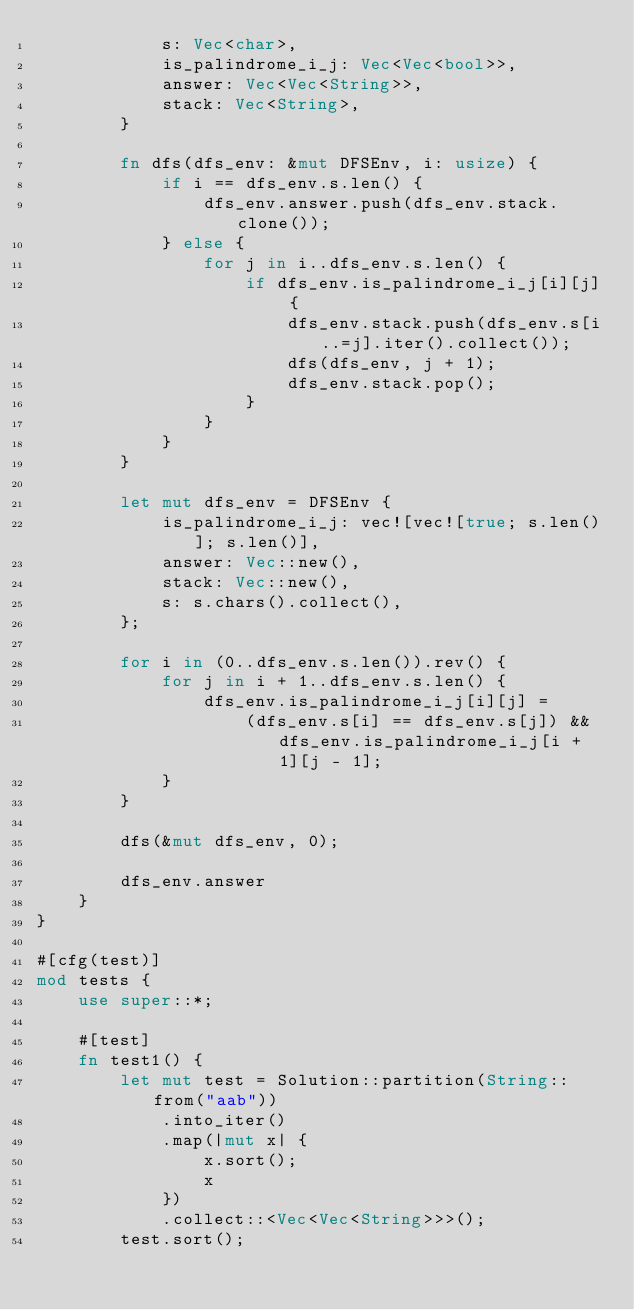Convert code to text. <code><loc_0><loc_0><loc_500><loc_500><_Rust_>            s: Vec<char>,
            is_palindrome_i_j: Vec<Vec<bool>>,
            answer: Vec<Vec<String>>,
            stack: Vec<String>,
        }

        fn dfs(dfs_env: &mut DFSEnv, i: usize) {
            if i == dfs_env.s.len() {
                dfs_env.answer.push(dfs_env.stack.clone());
            } else {
                for j in i..dfs_env.s.len() {
                    if dfs_env.is_palindrome_i_j[i][j] {
                        dfs_env.stack.push(dfs_env.s[i..=j].iter().collect());
                        dfs(dfs_env, j + 1);
                        dfs_env.stack.pop();
                    }
                }
            }
        }

        let mut dfs_env = DFSEnv {
            is_palindrome_i_j: vec![vec![true; s.len()]; s.len()],
            answer: Vec::new(),
            stack: Vec::new(),
            s: s.chars().collect(),
        };

        for i in (0..dfs_env.s.len()).rev() {
            for j in i + 1..dfs_env.s.len() {
                dfs_env.is_palindrome_i_j[i][j] =
                    (dfs_env.s[i] == dfs_env.s[j]) && dfs_env.is_palindrome_i_j[i + 1][j - 1];
            }
        }

        dfs(&mut dfs_env, 0);

        dfs_env.answer
    }
}

#[cfg(test)]
mod tests {
    use super::*;

    #[test]
    fn test1() {
        let mut test = Solution::partition(String::from("aab"))
            .into_iter()
            .map(|mut x| {
                x.sort();
                x
            })
            .collect::<Vec<Vec<String>>>();
        test.sort();
</code> 